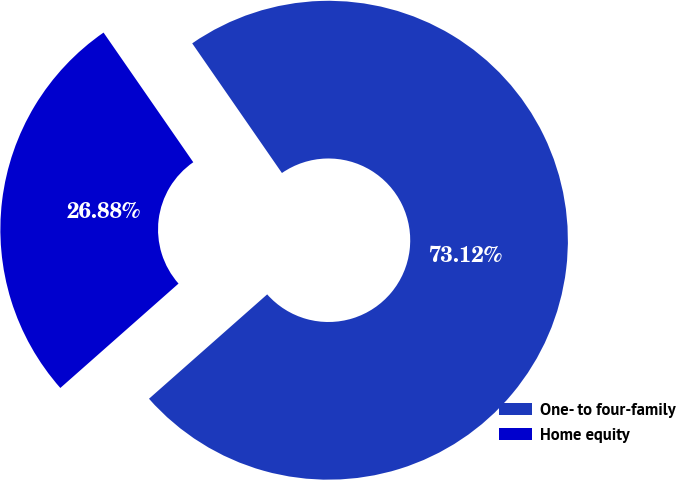Convert chart to OTSL. <chart><loc_0><loc_0><loc_500><loc_500><pie_chart><fcel>One- to four-family<fcel>Home equity<nl><fcel>73.12%<fcel>26.88%<nl></chart> 